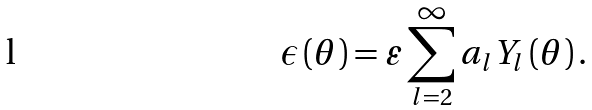<formula> <loc_0><loc_0><loc_500><loc_500>\epsilon \left ( \theta \right ) = \varepsilon \sum _ { l = 2 } ^ { \infty } a _ { l } Y _ { l } \left ( \theta \right ) .</formula> 